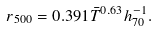<formula> <loc_0><loc_0><loc_500><loc_500>r _ { 5 0 0 } = 0 . 3 9 1 \bar { T } ^ { 0 . 6 3 } h _ { 7 0 } ^ { - 1 } .</formula> 